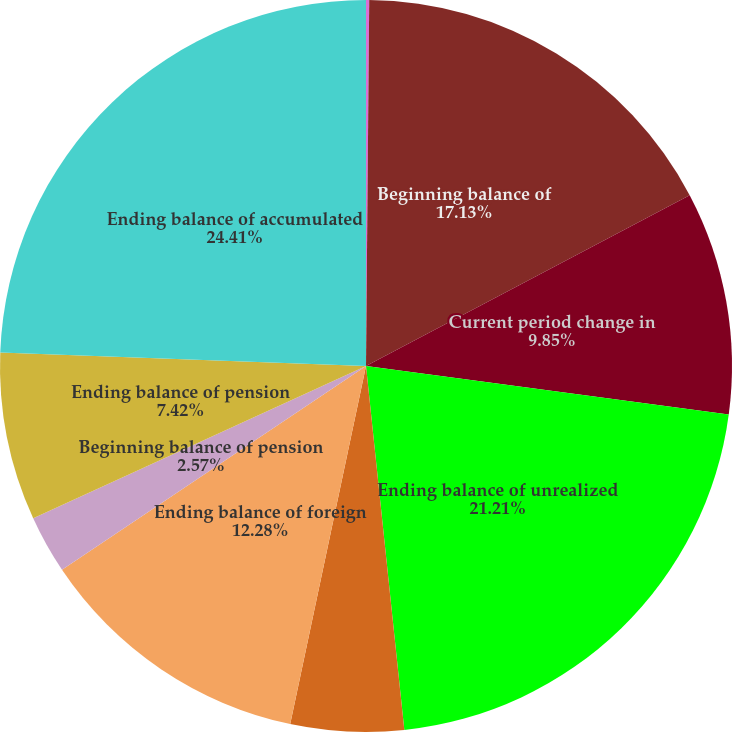<chart> <loc_0><loc_0><loc_500><loc_500><pie_chart><fcel>(Dollars in thousands)<fcel>Beginning balance of<fcel>Current period change in<fcel>Ending balance of unrealized<fcel>Beginning balance of foreign<fcel>Ending balance of foreign<fcel>Beginning balance of pension<fcel>Ending balance of pension<fcel>Ending balance of accumulated<nl><fcel>0.14%<fcel>17.13%<fcel>9.85%<fcel>21.21%<fcel>4.99%<fcel>12.28%<fcel>2.57%<fcel>7.42%<fcel>24.41%<nl></chart> 